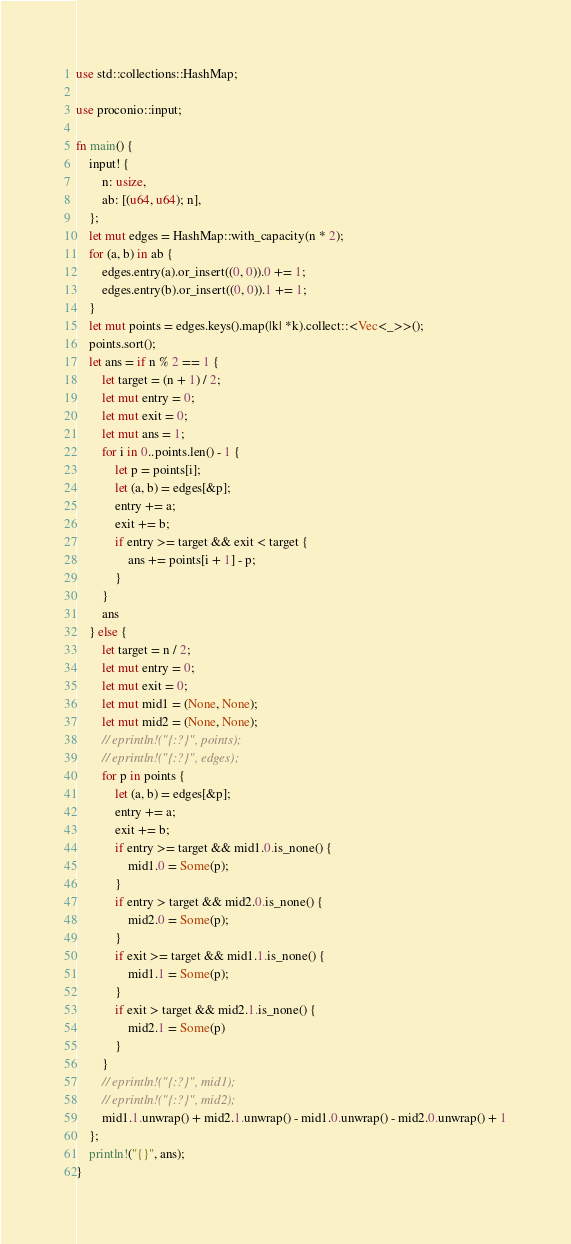Convert code to text. <code><loc_0><loc_0><loc_500><loc_500><_Rust_>use std::collections::HashMap;

use proconio::input;

fn main() {
    input! {
        n: usize,
        ab: [(u64, u64); n],
    };
    let mut edges = HashMap::with_capacity(n * 2);
    for (a, b) in ab {
        edges.entry(a).or_insert((0, 0)).0 += 1;
        edges.entry(b).or_insert((0, 0)).1 += 1;
    }
    let mut points = edges.keys().map(|k| *k).collect::<Vec<_>>();
    points.sort();
    let ans = if n % 2 == 1 {
        let target = (n + 1) / 2;
        let mut entry = 0;
        let mut exit = 0;
        let mut ans = 1;
        for i in 0..points.len() - 1 {
            let p = points[i];
            let (a, b) = edges[&p];
            entry += a;
            exit += b;
            if entry >= target && exit < target {
                ans += points[i + 1] - p;
            }
        }
        ans
    } else {
        let target = n / 2;
        let mut entry = 0;
        let mut exit = 0;
        let mut mid1 = (None, None);
        let mut mid2 = (None, None);
        // eprintln!("{:?}", points);
        // eprintln!("{:?}", edges);
        for p in points {
            let (a, b) = edges[&p];
            entry += a;
            exit += b;
            if entry >= target && mid1.0.is_none() {
                mid1.0 = Some(p);
            }
            if entry > target && mid2.0.is_none() {
                mid2.0 = Some(p);
            }
            if exit >= target && mid1.1.is_none() {
                mid1.1 = Some(p);
            }
            if exit > target && mid2.1.is_none() {
                mid2.1 = Some(p)
            }
        }
        // eprintln!("{:?}", mid1);
        // eprintln!("{:?}", mid2);
        mid1.1.unwrap() + mid2.1.unwrap() - mid1.0.unwrap() - mid2.0.unwrap() + 1
    };
    println!("{}", ans);
}
</code> 